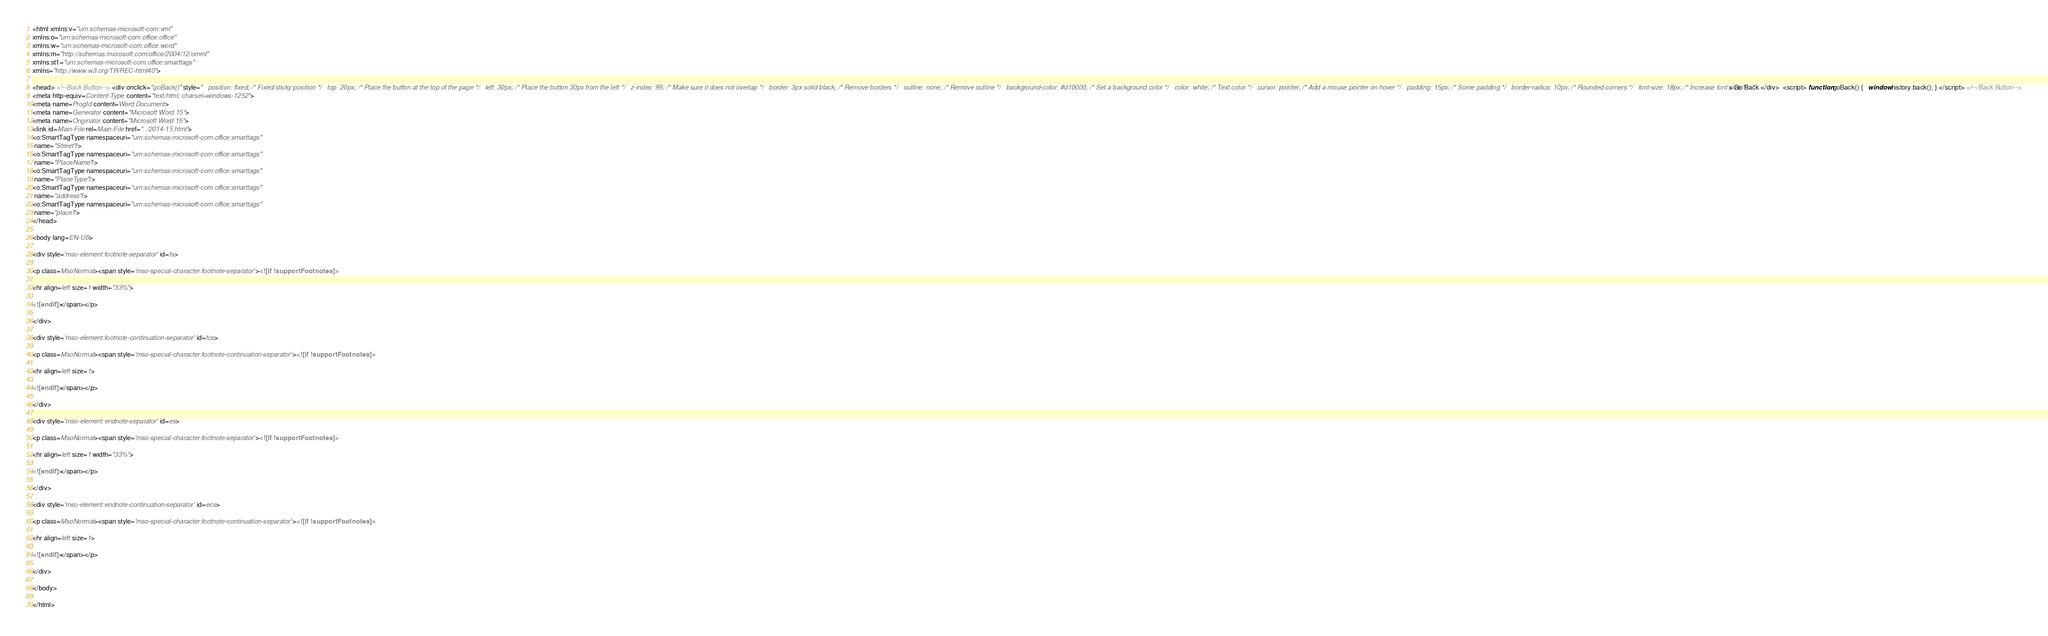Convert code to text. <code><loc_0><loc_0><loc_500><loc_500><_HTML_><html xmlns:v="urn:schemas-microsoft-com:vml"
xmlns:o="urn:schemas-microsoft-com:office:office"
xmlns:w="urn:schemas-microsoft-com:office:word"
xmlns:m="http://schemas.microsoft.com/office/2004/12/omml"
xmlns:st1="urn:schemas-microsoft-com:office:smarttags"
xmlns="http://www.w3.org/TR/REC-html40">

<head> <!--Back Button--> <div onclick="goBack()" style="   position: fixed; /* Fixed/sticky position */   top: 20px; /* Place the button at the top of the page */   left: 30px; /* Place the button 30px from the left */   z-index: 99; /* Make sure it does not overlap */   border: 3px solid black; /* Remove borders */   outline: none; /* Remove outline */   background-color: #d10000; /* Set a background color */   color: white; /* Text color */   cursor: pointer; /* Add a mouse pointer on hover */   padding: 15px; /* Some padding */   border-radius: 10px; /* Rounded corners */   font-size: 18px; /* Increase font size */   "> Go Back </div>  <script> function goBack() {   window.history.back(); } </script> <!--/Back Button-->
<meta http-equiv=Content-Type content="text/html; charset=windows-1252">
<meta name=ProgId content=Word.Document>
<meta name=Generator content="Microsoft Word 15">
<meta name=Originator content="Microsoft Word 15">
<link id=Main-File rel=Main-File href="../2014-15.html">
<o:SmartTagType namespaceuri="urn:schemas-microsoft-com:office:smarttags"
 name="Street"/>
<o:SmartTagType namespaceuri="urn:schemas-microsoft-com:office:smarttags"
 name="PlaceName"/>
<o:SmartTagType namespaceuri="urn:schemas-microsoft-com:office:smarttags"
 name="PlaceType"/>
<o:SmartTagType namespaceuri="urn:schemas-microsoft-com:office:smarttags"
 name="address"/>
<o:SmartTagType namespaceuri="urn:schemas-microsoft-com:office:smarttags"
 name="place"/>
</head>

<body lang=EN-US>

<div style='mso-element:footnote-separator' id=fs>

<p class=MsoNormal><span style='mso-special-character:footnote-separator'><![if !supportFootnotes]>

<hr align=left size=1 width="33%">

<![endif]></span></p>

</div>

<div style='mso-element:footnote-continuation-separator' id=fcs>

<p class=MsoNormal><span style='mso-special-character:footnote-continuation-separator'><![if !supportFootnotes]>

<hr align=left size=1>

<![endif]></span></p>

</div>

<div style='mso-element:endnote-separator' id=es>

<p class=MsoNormal><span style='mso-special-character:footnote-separator'><![if !supportFootnotes]>

<hr align=left size=1 width="33%">

<![endif]></span></p>

</div>

<div style='mso-element:endnote-continuation-separator' id=ecs>

<p class=MsoNormal><span style='mso-special-character:footnote-continuation-separator'><![if !supportFootnotes]>

<hr align=left size=1>

<![endif]></span></p>

</div>

</body>

</html>
</code> 